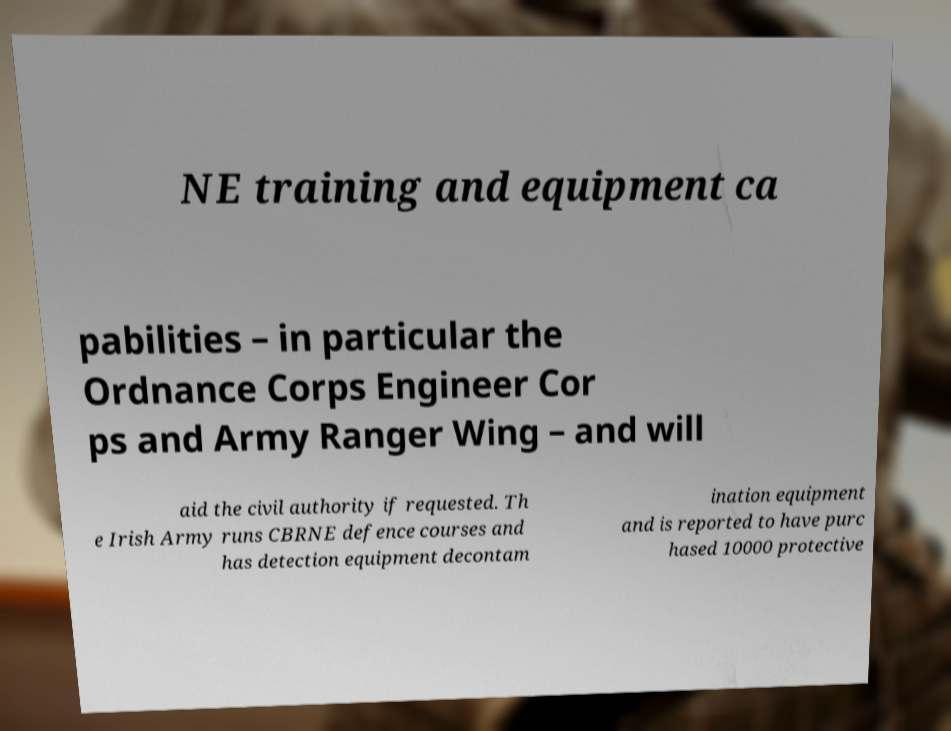For documentation purposes, I need the text within this image transcribed. Could you provide that? NE training and equipment ca pabilities – in particular the Ordnance Corps Engineer Cor ps and Army Ranger Wing – and will aid the civil authority if requested. Th e Irish Army runs CBRNE defence courses and has detection equipment decontam ination equipment and is reported to have purc hased 10000 protective 